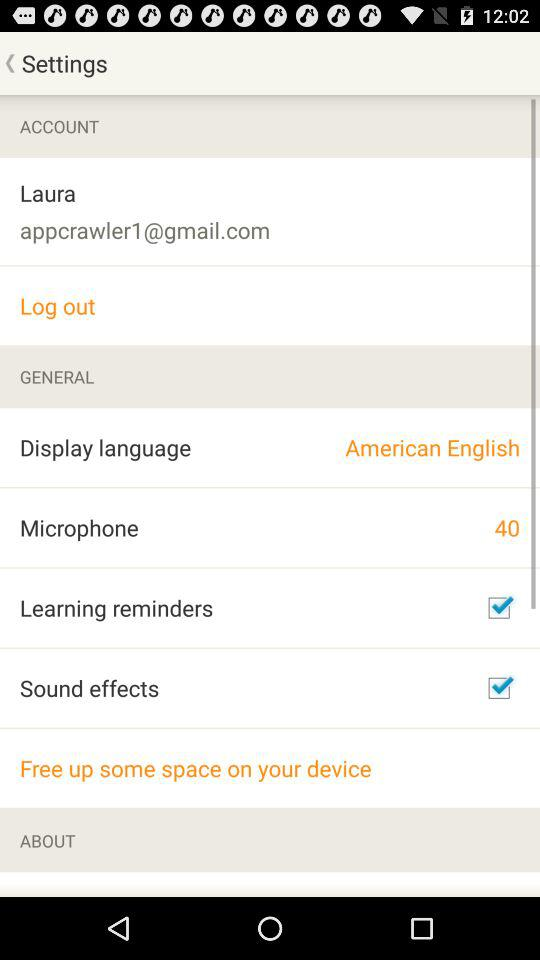What is the email address of the user? The email address is appcrawler1@gmail.com. 